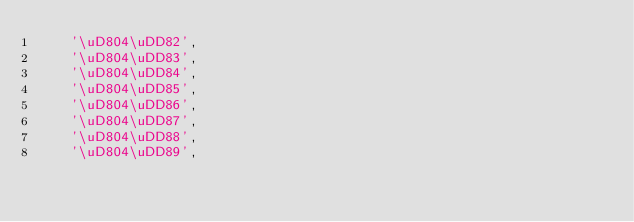Convert code to text. <code><loc_0><loc_0><loc_500><loc_500><_JavaScript_>	'\uD804\uDD82',
	'\uD804\uDD83',
	'\uD804\uDD84',
	'\uD804\uDD85',
	'\uD804\uDD86',
	'\uD804\uDD87',
	'\uD804\uDD88',
	'\uD804\uDD89',</code> 